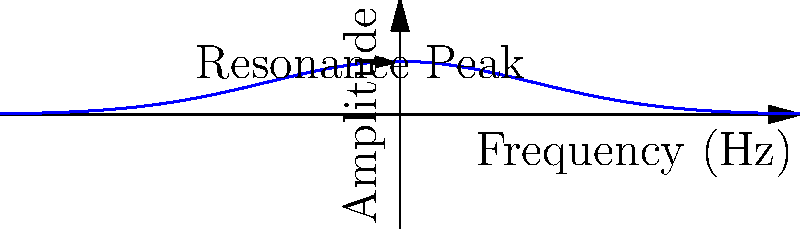In developing a meditation app, you want to incorporate a sound feature that resonates with the natural frequency of brain waves during deep meditation. Research suggests this frequency is approximately 7 Hz. If you design a sound chamber in the app that has a length of 24.5 meters, what should be the temperature of the virtual environment to achieve this resonance frequency? Assume the speed of sound in air at 20°C is 343 m/s and it changes by 0.6 m/s for every 1°C change in temperature. Let's approach this step-by-step:

1) The formula for resonance frequency is:
   $f = \frac{v}{2L}$
   Where $f$ is frequency, $v$ is speed of sound, and $L$ is length of the chamber.

2) We know $f = 7$ Hz and $L = 24.5$ m. Let's solve for $v$:
   $7 = \frac{v}{2(24.5)}$
   $v = 7 * 2 * 24.5 = 343$ m/s

3) Interestingly, this is the speed of sound at 20°C. But we need to verify if this is indeed the temperature we need.

4) The relationship between temperature and speed of sound is:
   $v_T = v_0 + 0.6(T - 20)$
   Where $v_T$ is the speed at temperature $T$, and $v_0$ is the speed at 20°C.

5) Substituting our values:
   $343 = 343 + 0.6(T - 20)$
   $0 = 0.6(T - 20)$
   $T - 20 = 0$
   $T = 20°C$

Therefore, the temperature should be set to 20°C in the virtual environment.
Answer: 20°C 